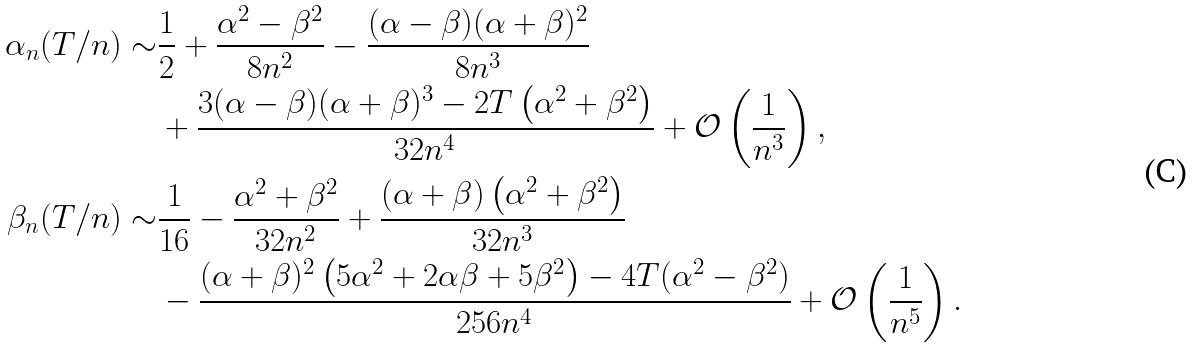Convert formula to latex. <formula><loc_0><loc_0><loc_500><loc_500>\alpha _ { n } ( T / n ) \sim & \frac { 1 } { 2 } + \frac { \alpha ^ { 2 } - \beta ^ { 2 } } { 8 n ^ { 2 } } - \frac { ( \alpha - \beta ) ( \alpha + \beta ) ^ { 2 } } { 8 n ^ { 3 } } \\ & + \frac { 3 ( \alpha - \beta ) ( \alpha + \beta ) ^ { 3 } - 2 T \left ( \alpha ^ { 2 } + \beta ^ { 2 } \right ) } { 3 2 n ^ { 4 } } + \mathcal { O } \left ( \frac { 1 } { n ^ { 3 } } \right ) , \\ \beta _ { n } ( T / n ) \sim & \frac { 1 } { 1 6 } - \frac { \alpha ^ { 2 } + \beta ^ { 2 } } { 3 2 n ^ { 2 } } + \frac { ( \alpha + \beta ) \left ( \alpha ^ { 2 } + \beta ^ { 2 } \right ) } { 3 2 n ^ { 3 } } \\ & - \frac { ( \alpha + \beta ) ^ { 2 } \left ( 5 \alpha ^ { 2 } + 2 \alpha \beta + 5 \beta ^ { 2 } \right ) - 4 T ( \alpha ^ { 2 } - \beta ^ { 2 } ) } { 2 5 6 n ^ { 4 } } + \mathcal { O } \left ( \frac { 1 } { n ^ { 5 } } \right ) .</formula> 